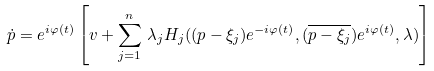<formula> <loc_0><loc_0><loc_500><loc_500>\dot { p } & = e ^ { i \varphi ( t ) } \left [ v + \sum _ { j = 1 } ^ { n } \, \lambda _ { j } H _ { j } ( ( p - \xi _ { j } ) e ^ { - i \varphi ( t ) } , ( \overline { p - \xi _ { j } } ) e ^ { i \varphi ( t ) } , \lambda ) \right ]</formula> 